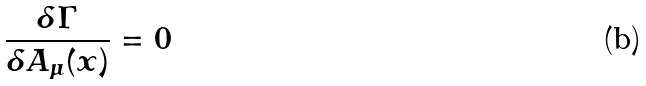Convert formula to latex. <formula><loc_0><loc_0><loc_500><loc_500>\frac { \delta \Gamma } { \delta A _ { \mu } ( x ) } = 0</formula> 